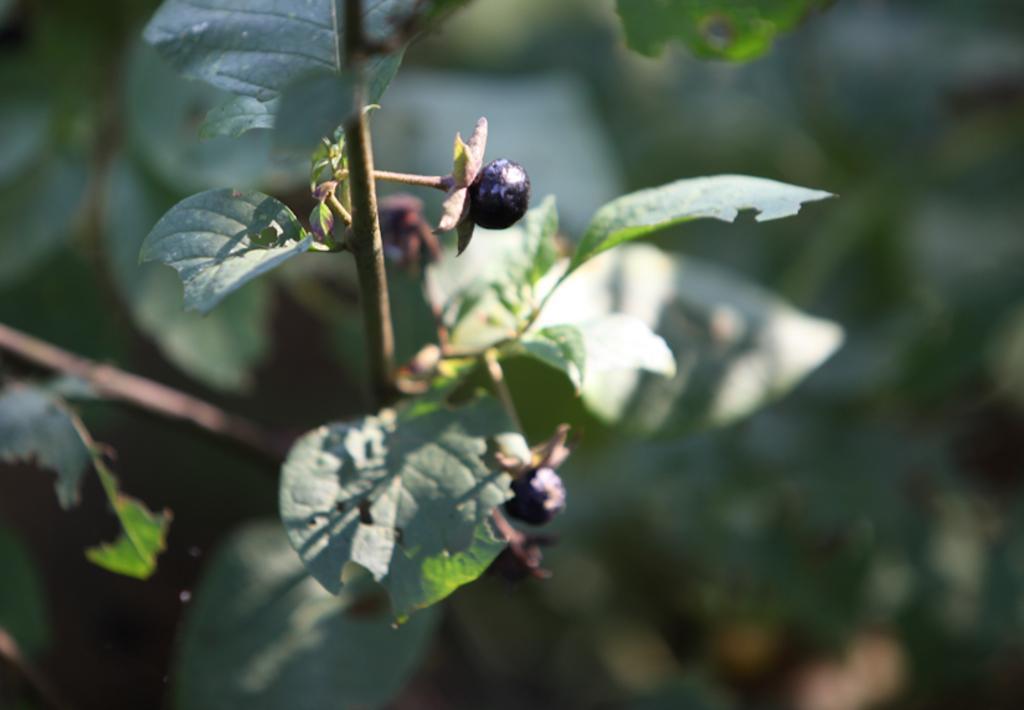In one or two sentences, can you explain what this image depicts? In this picture we observe leaves which has blueberries attached to it. 